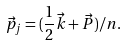Convert formula to latex. <formula><loc_0><loc_0><loc_500><loc_500>\vec { p } _ { j } = ( { \frac { 1 } { 2 } } \vec { k } + \vec { P } ) / n .</formula> 